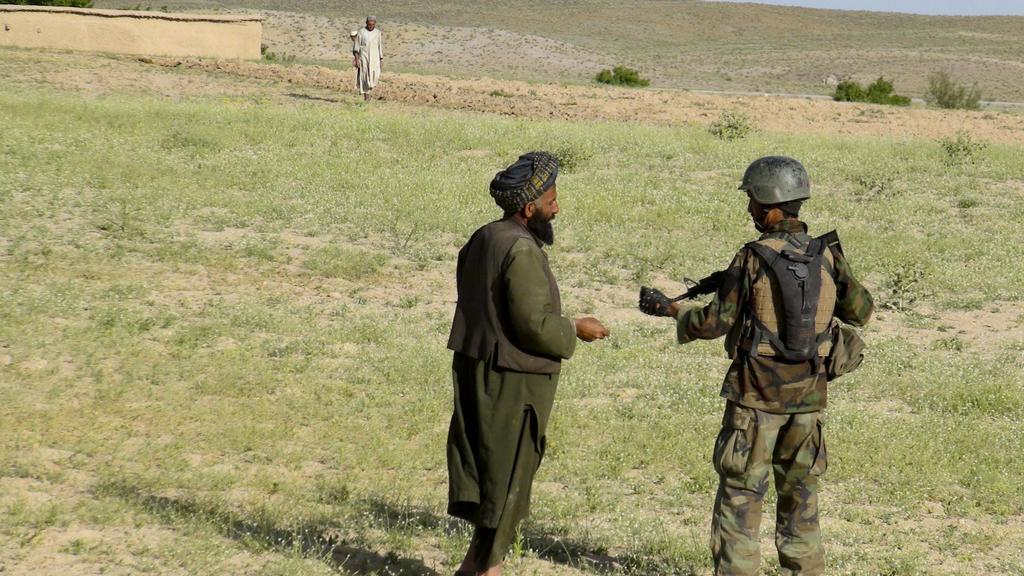How many people are standing on the grass in the image? There are two persons standing on the grass in the image. What is one of the persons holding? One of the persons is holding a gun. Can you describe the background of the image? There is a person standing in the background and a wall in the background. What type of rest can be seen in the cemetery in the image? There is no cemetery present in the image, and therefore no rest can be observed. 